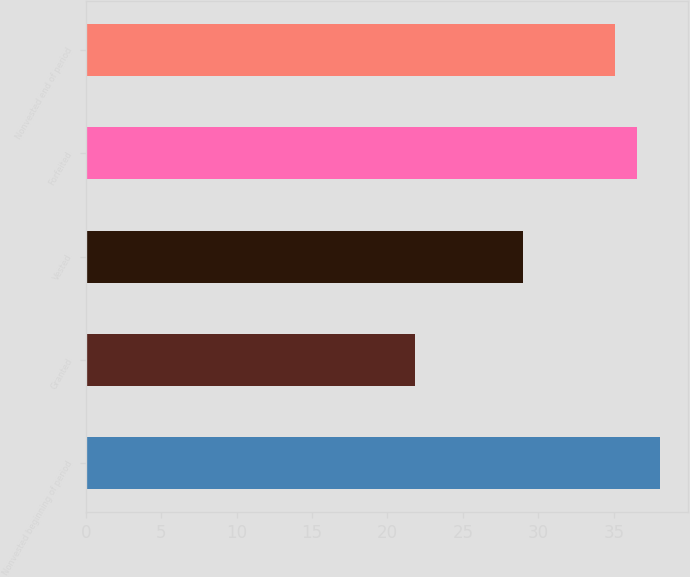Convert chart to OTSL. <chart><loc_0><loc_0><loc_500><loc_500><bar_chart><fcel>Nonvested beginning of period<fcel>Granted<fcel>Vested<fcel>Forfeited<fcel>Nonvested end of period<nl><fcel>38.04<fcel>21.85<fcel>28.98<fcel>36.57<fcel>35.1<nl></chart> 